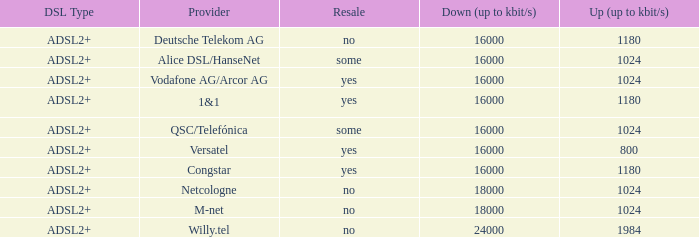What are the various dsl types provided by m-net telecom company? ADSL2+. 